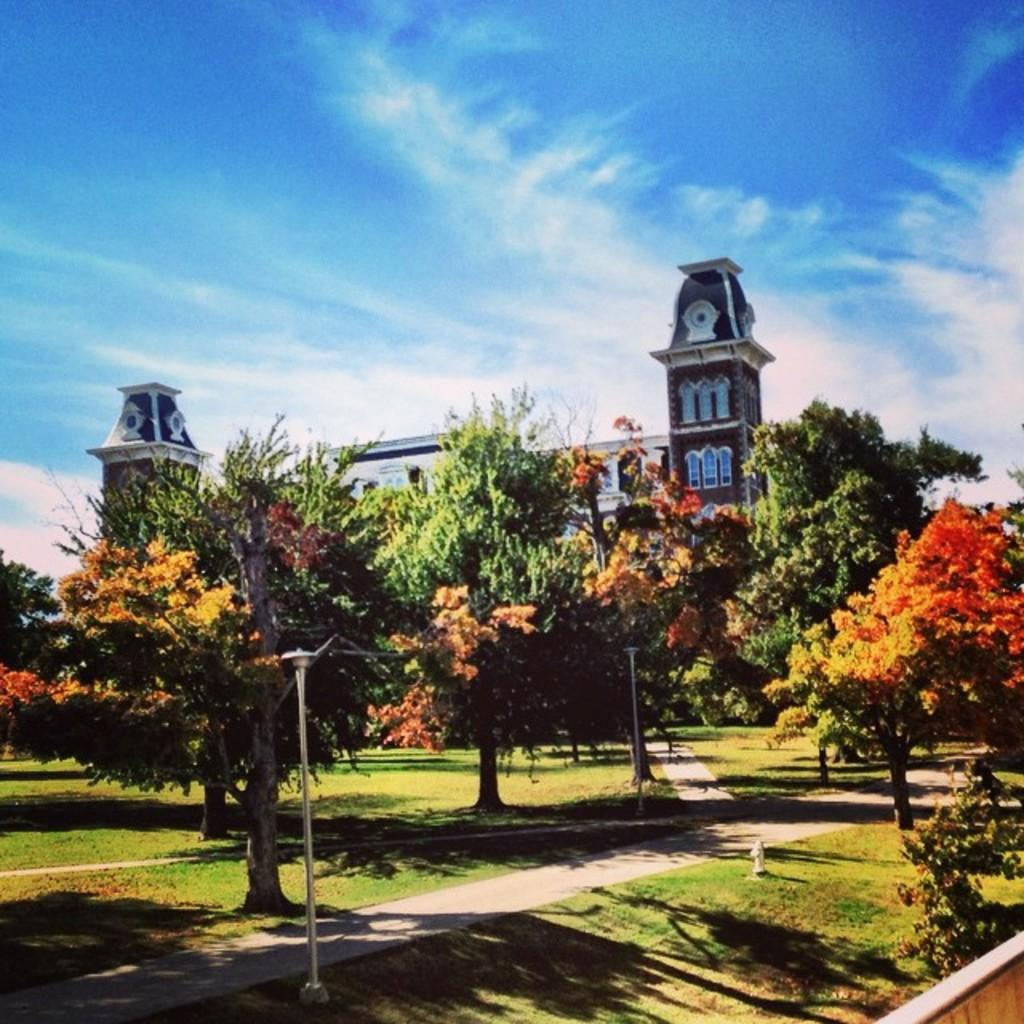What type of vegetation can be seen in the image? There are trees and plants in the image. What type of structure is present in the image? There is a building in the image. What is at the bottom of the image? There is a walkway and grass at the bottom of the image, along with some objects. What is visible at the top of the image? The sky is visible at the top of the image. How long does it take for the paper to pass through the alley in the image? There is no paper or alley present in the image. What type of alley can be seen in the image? There is no alley present in the image. 